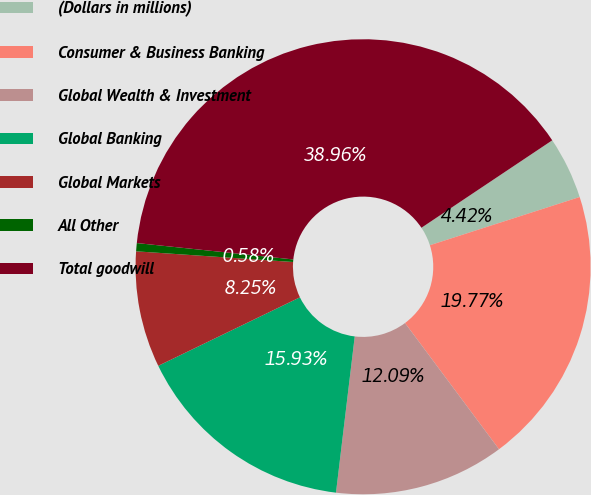Convert chart to OTSL. <chart><loc_0><loc_0><loc_500><loc_500><pie_chart><fcel>(Dollars in millions)<fcel>Consumer & Business Banking<fcel>Global Wealth & Investment<fcel>Global Banking<fcel>Global Markets<fcel>All Other<fcel>Total goodwill<nl><fcel>4.42%<fcel>19.77%<fcel>12.09%<fcel>15.93%<fcel>8.25%<fcel>0.58%<fcel>38.96%<nl></chart> 